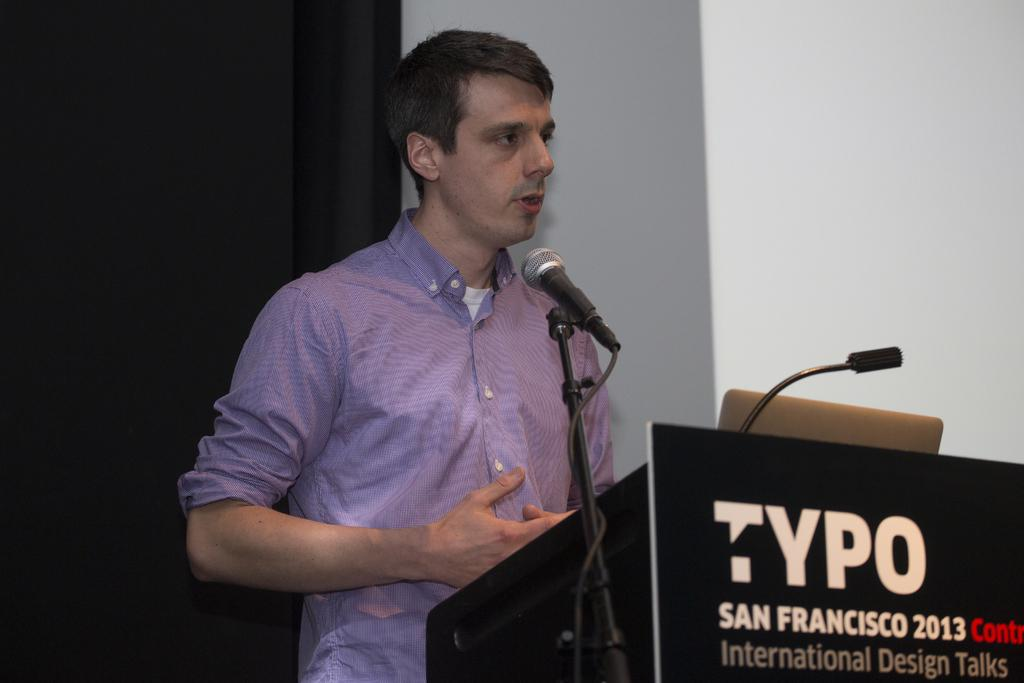What is the main subject of the image? There is a man standing in the image. What object is visible near the man? There is a microphone in the image. What type of structure can be seen in the background? There is a wall in the image. What type of skirt is the animal wearing in the image? There is no animal or skirt present in the image. How does the society depicted in the image influence the man's actions? The image does not depict a society or any societal influence on the man's actions. 